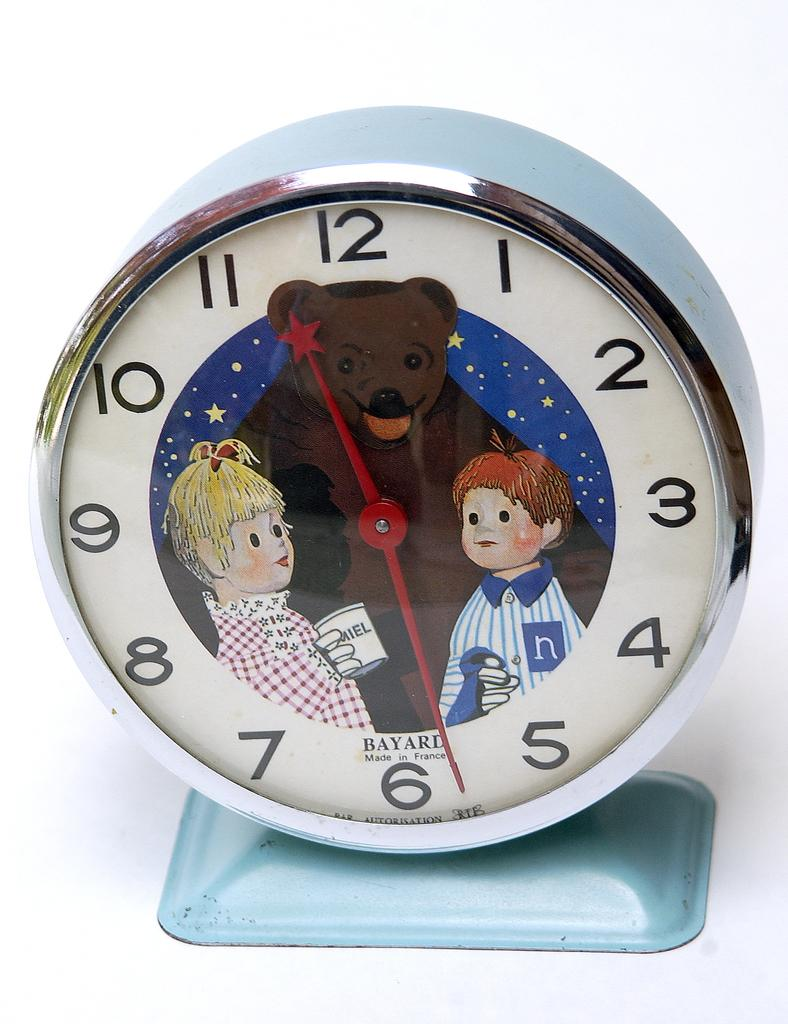Provide a one-sentence caption for the provided image. A clock which was made in France has a drawing of a bear next to a boy and a girl. 